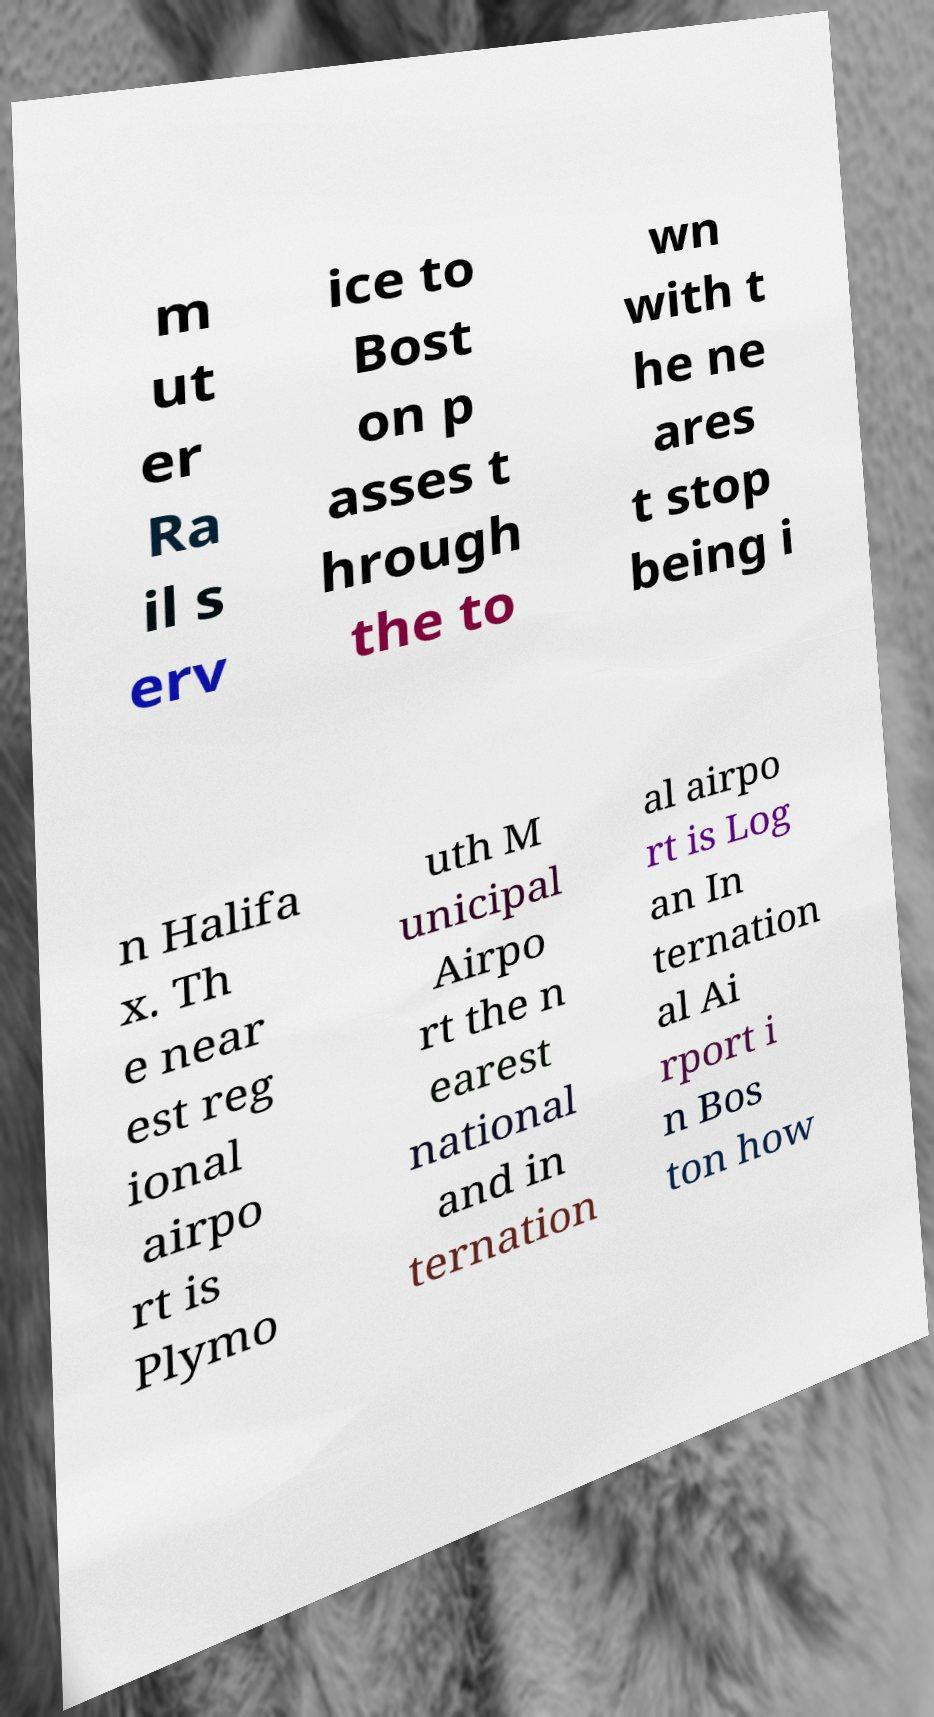There's text embedded in this image that I need extracted. Can you transcribe it verbatim? m ut er Ra il s erv ice to Bost on p asses t hrough the to wn with t he ne ares t stop being i n Halifa x. Th e near est reg ional airpo rt is Plymo uth M unicipal Airpo rt the n earest national and in ternation al airpo rt is Log an In ternation al Ai rport i n Bos ton how 